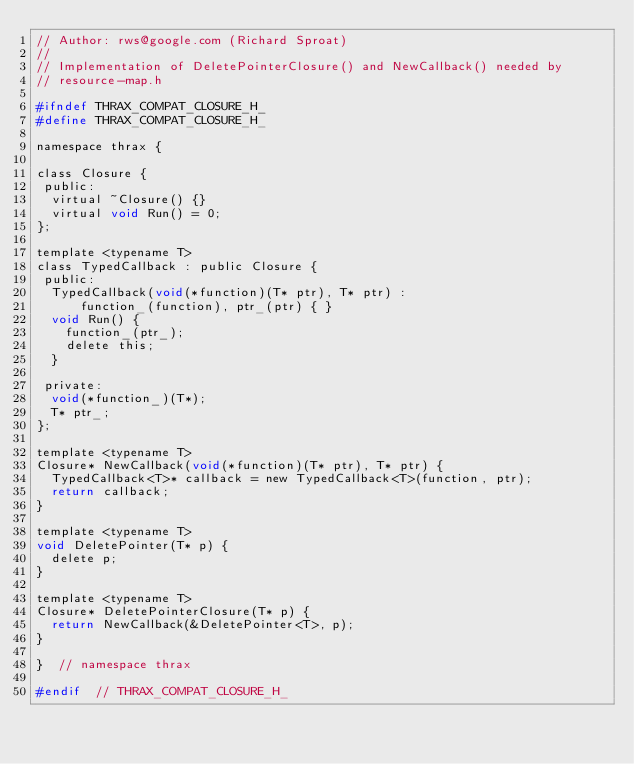Convert code to text. <code><loc_0><loc_0><loc_500><loc_500><_C_>// Author: rws@google.com (Richard Sproat)
//
// Implementation of DeletePointerClosure() and NewCallback() needed by
// resource-map.h

#ifndef THRAX_COMPAT_CLOSURE_H_
#define THRAX_COMPAT_CLOSURE_H_

namespace thrax {

class Closure {
 public:
  virtual ~Closure() {}
  virtual void Run() = 0;
};

template <typename T>
class TypedCallback : public Closure {
 public:
  TypedCallback(void(*function)(T* ptr), T* ptr) :
      function_(function), ptr_(ptr) { }
  void Run() {
    function_(ptr_);
    delete this;
  }

 private:
  void(*function_)(T*);
  T* ptr_;
};

template <typename T>
Closure* NewCallback(void(*function)(T* ptr), T* ptr) {
  TypedCallback<T>* callback = new TypedCallback<T>(function, ptr);
  return callback;
}

template <typename T>
void DeletePointer(T* p) {
  delete p;
}

template <typename T>
Closure* DeletePointerClosure(T* p) {
  return NewCallback(&DeletePointer<T>, p);
}

}  // namespace thrax

#endif  // THRAX_COMPAT_CLOSURE_H_
</code> 